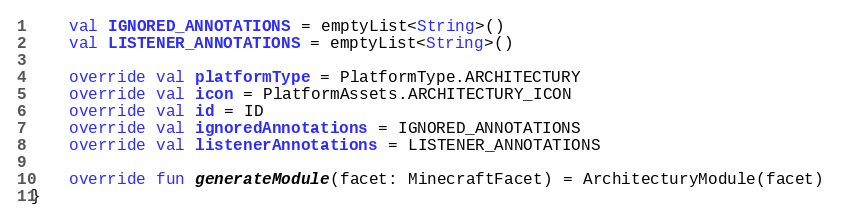Convert code to text. <code><loc_0><loc_0><loc_500><loc_500><_Kotlin_>
    val IGNORED_ANNOTATIONS = emptyList<String>()
    val LISTENER_ANNOTATIONS = emptyList<String>()

    override val platformType = PlatformType.ARCHITECTURY
    override val icon = PlatformAssets.ARCHITECTURY_ICON
    override val id = ID
    override val ignoredAnnotations = IGNORED_ANNOTATIONS
    override val listenerAnnotations = LISTENER_ANNOTATIONS

    override fun generateModule(facet: MinecraftFacet) = ArchitecturyModule(facet)
}
</code> 